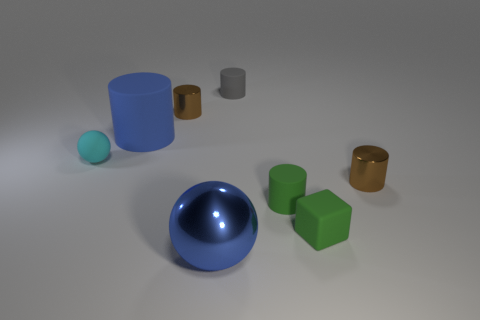Subtract 1 cylinders. How many cylinders are left? 4 Subtract all green cylinders. How many cylinders are left? 4 Subtract all small gray cylinders. How many cylinders are left? 4 Subtract all purple cylinders. Subtract all yellow cubes. How many cylinders are left? 5 Add 1 big purple things. How many objects exist? 9 Subtract all cylinders. How many objects are left? 3 Subtract 0 green balls. How many objects are left? 8 Subtract all blocks. Subtract all metallic spheres. How many objects are left? 6 Add 3 gray objects. How many gray objects are left? 4 Add 4 small purple metallic cubes. How many small purple metallic cubes exist? 4 